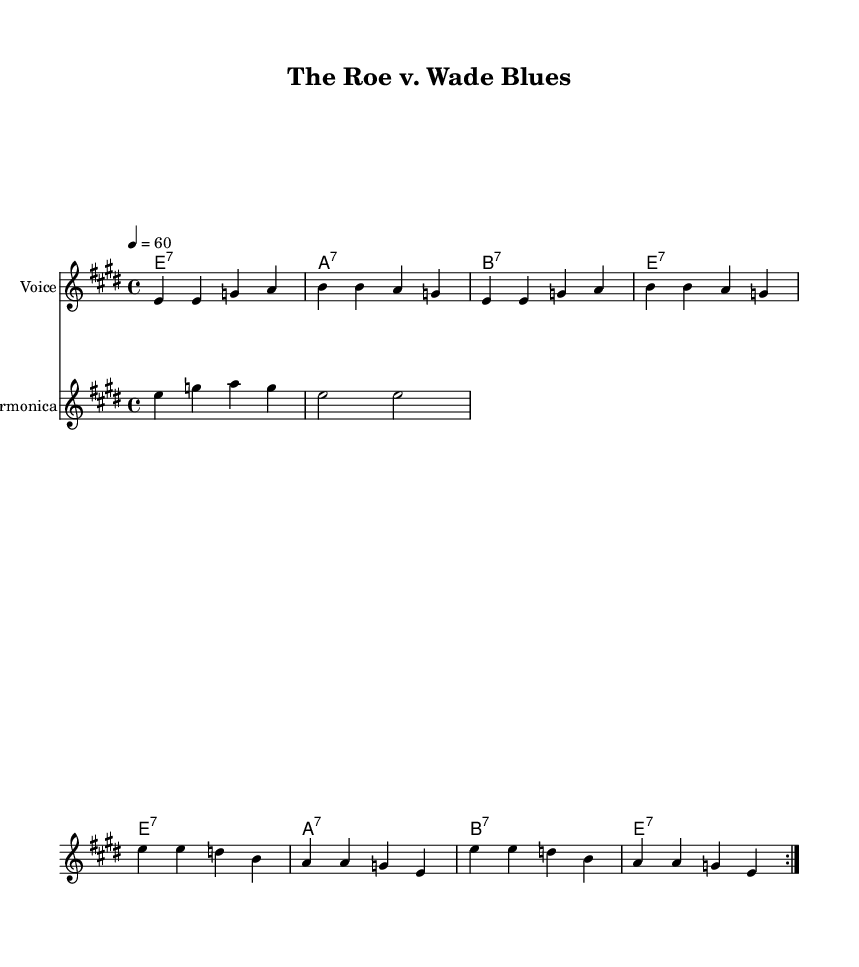What is the key signature of this music? The key signature is E major, indicated by four sharps (F#, C#, G#, and D#). It is shown at the beginning of the staff.
Answer: E major What is the time signature of this piece? The time signature is 4/4, meaning there are four beats per measure, as indicated at the beginning of the score.
Answer: 4/4 What is the tempo marking for this composition? The tempo marking indicates a speed of 60 beats per minute, specified at the beginning of the score with "4 = 60".
Answer: 60 How many measures are in the verse? The verse consists of eight measures, counted through the repeated sections and confirming the structure of the lyrics.
Answer: 8 What is the main theme of the lyrics? The lyrics recount the historical case of Roe v. Wade and its implications on privacy rights and women's choice, which is the central theme of the song.
Answer: Roe v. Wade What type of instrument is included in the score alongside the voice? The score includes a harmonica along with the voice, as indicated by the separate staff labeled "Harmonica".
Answer: Harmonica Identify a characteristic feature of the Blues genre present in this piece. A characteristic feature of Blues in this piece is the use of call-and-response in the lyrics and the harmonica riff, common in traditional blues music.
Answer: Call-and-response 